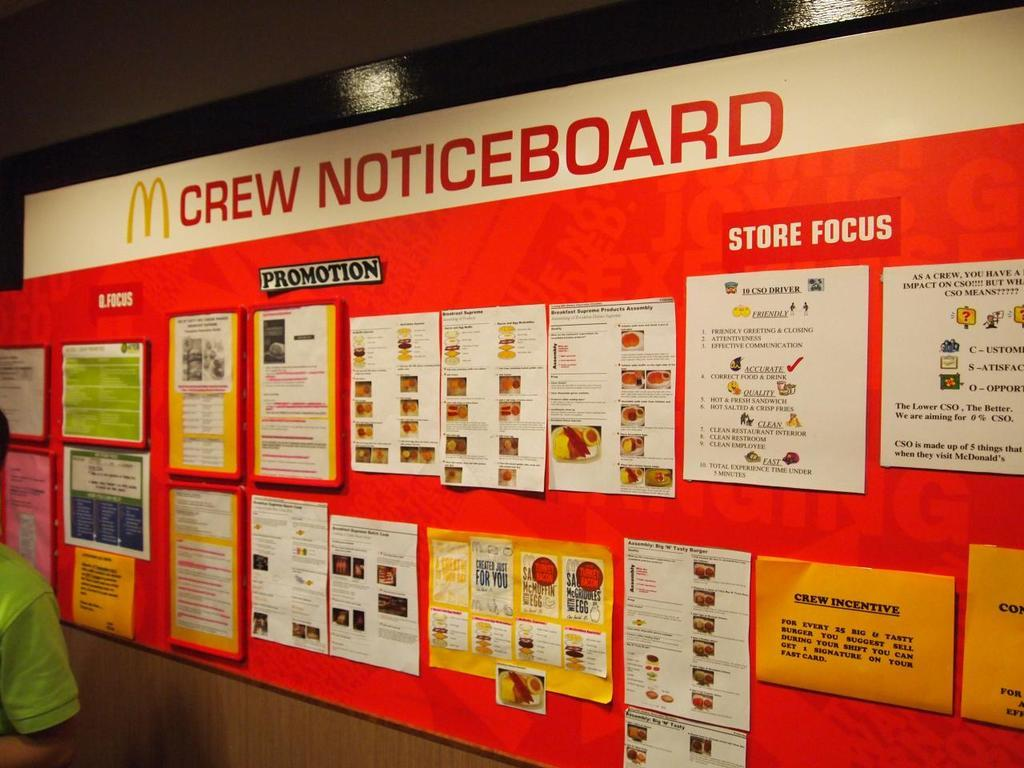<image>
Present a compact description of the photo's key features. A red board called the M Crew Noticeboard. 